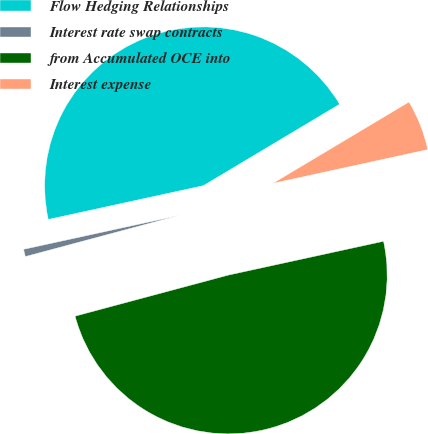Convert chart. <chart><loc_0><loc_0><loc_500><loc_500><pie_chart><fcel>Flow Hedging Relationships<fcel>Interest rate swap contracts<fcel>from Accumulated OCE into<fcel>Interest expense<nl><fcel>44.84%<fcel>0.75%<fcel>49.25%<fcel>5.16%<nl></chart> 